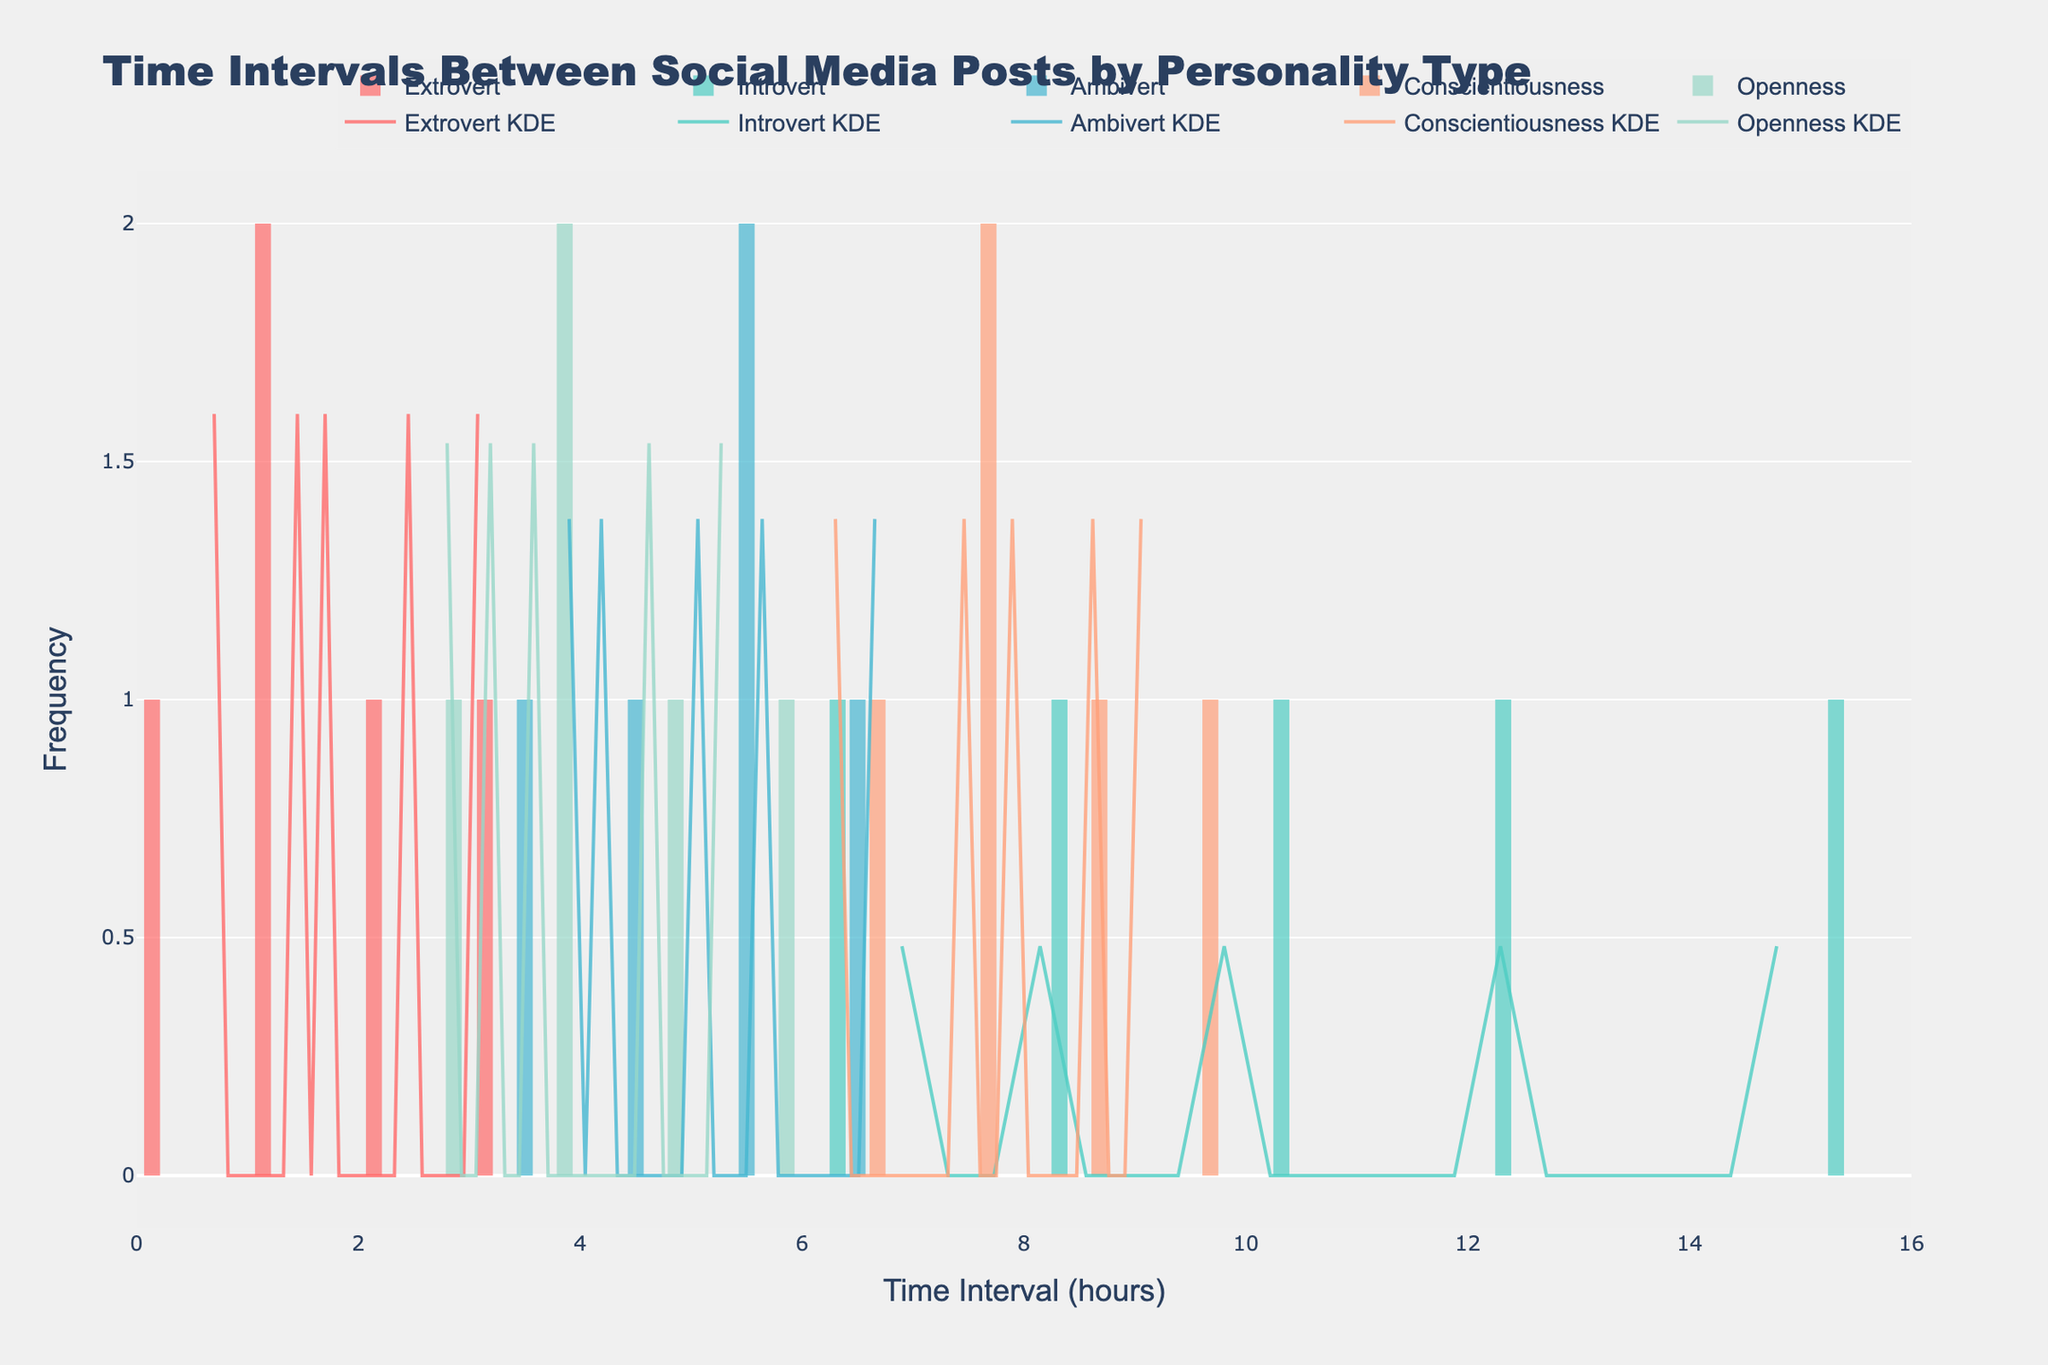Which personality type has the shortest time interval between social media posts most frequently? To determine the personality type that has the shortest time interval between posts, visually inspect the histogram bars at the lower end of the time interval axis (close to zero). The Extrovert category has the highest frequency in the shortest time interval range.
Answer: Extrovert Which personality type has the longest time intervals between social media posts? Look at the histogram for which personality type reaches the highest time intervals on the x-axis. The Introvert category extends to the highest time intervals, up to around 15.2 hours.
Answer: Introvert How does the median of the time intervals for Ambiverts compare to that for Introverts? Identify the middle value of the time intervals for both Ambiverts and Introverts from the histogram. For Ambiverts, the time intervals concentrate around the middle at about 4 to 6 hours. For Introverts, median values are considerably higher as they spread around the 7 to 12 hours range.
Answer: Ambiverts have a lower median time interval compared to Introverts Which personality type has the densest concentration of time intervals around 3 hours according to the KDE curve? Find the KDE (density) curve near the 3-hour mark on the x-axis and see which curve peaks near this value. The Extrovert category shows the densest concentration near this value due to the peak in their KDE curve around 3 hours.
Answer: Extrovert Describe the distribution of time intervals for the Openness personality type. Observing the histogram and KDE curve for Openness, the time intervals range mostly between 2.8 and 5.4 hours, with the highest frequencies around 3 to 4 hours, and a gentle density curve peaking around these values, indicating a fairly consistent posting pattern.
Answer: Mostly between 2.8 and 5.4 hours, peak around 3 to 4 hours What overall pattern can be observed in the posting times of Conscientiousness personality type? By examining the histogram and density curve of Conscientiousness, it is evident that posting times are relatively consistently spread between 6.3 and 9.2 hours, with a slight peak near 8 hours, suggesting a moderate frequency of posting with systematic intervals.
Answer: Consistently spread between 6.3 and 9.2 hours, peak near 8 hours Which personality type has the lowest variability in the time intervals between posts? Compare the spread of all histograms. The Extrovert category has a smaller range of time intervals (around 0.7 to 3.2 hours), indicating lower variability compared to the wider range of the other categories like Introvert.
Answer: Extrovert 